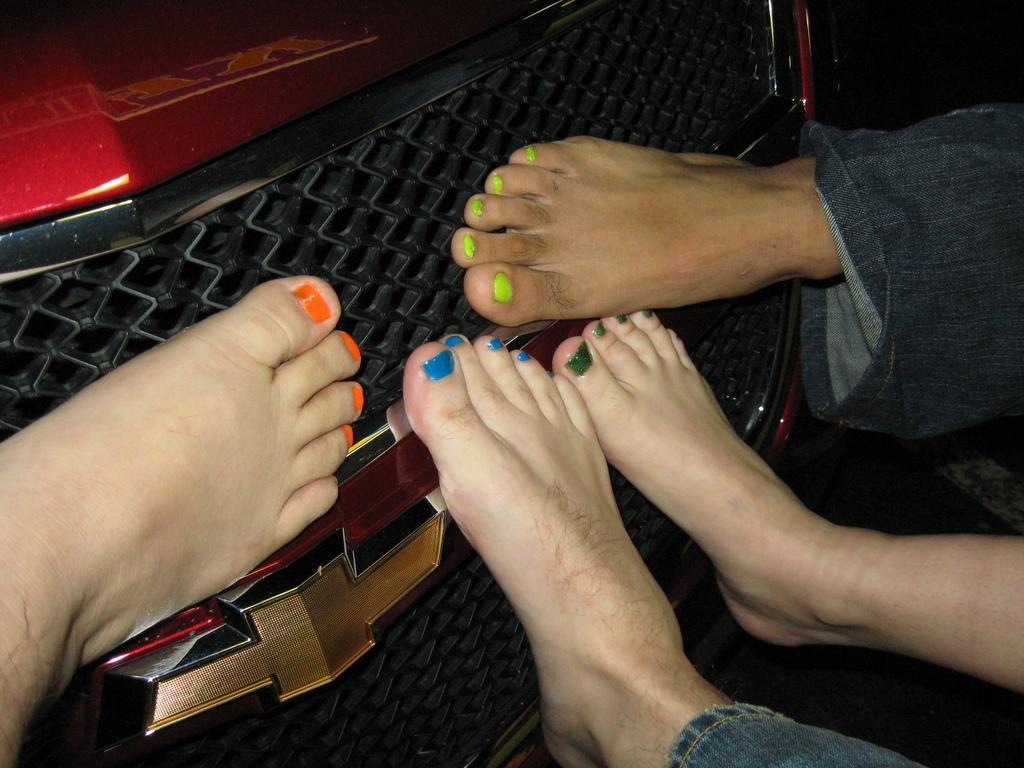Could you give a brief overview of what you see in this image? In this image I see 4 legs and I see the nail paints on the nails and I see the front part of the car over here and I see the logo. 